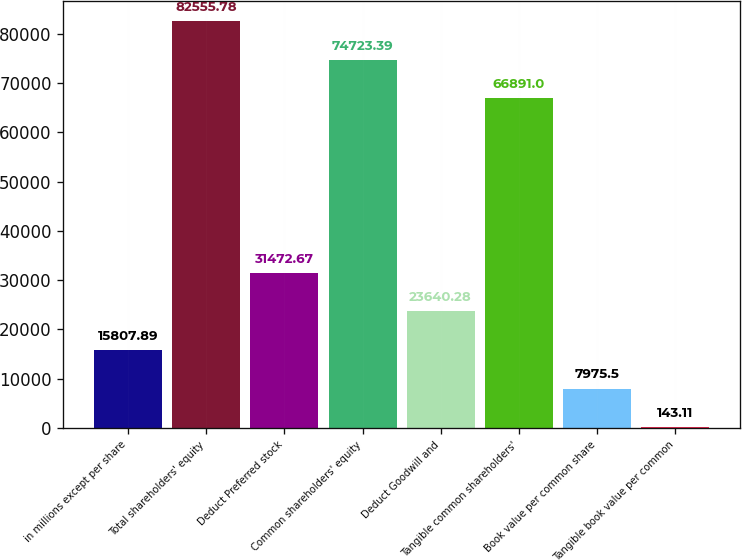Convert chart. <chart><loc_0><loc_0><loc_500><loc_500><bar_chart><fcel>in millions except per share<fcel>Total shareholders' equity<fcel>Deduct Preferred stock<fcel>Common shareholders' equity<fcel>Deduct Goodwill and<fcel>Tangible common shareholders'<fcel>Book value per common share<fcel>Tangible book value per common<nl><fcel>15807.9<fcel>82555.8<fcel>31472.7<fcel>74723.4<fcel>23640.3<fcel>66891<fcel>7975.5<fcel>143.11<nl></chart> 